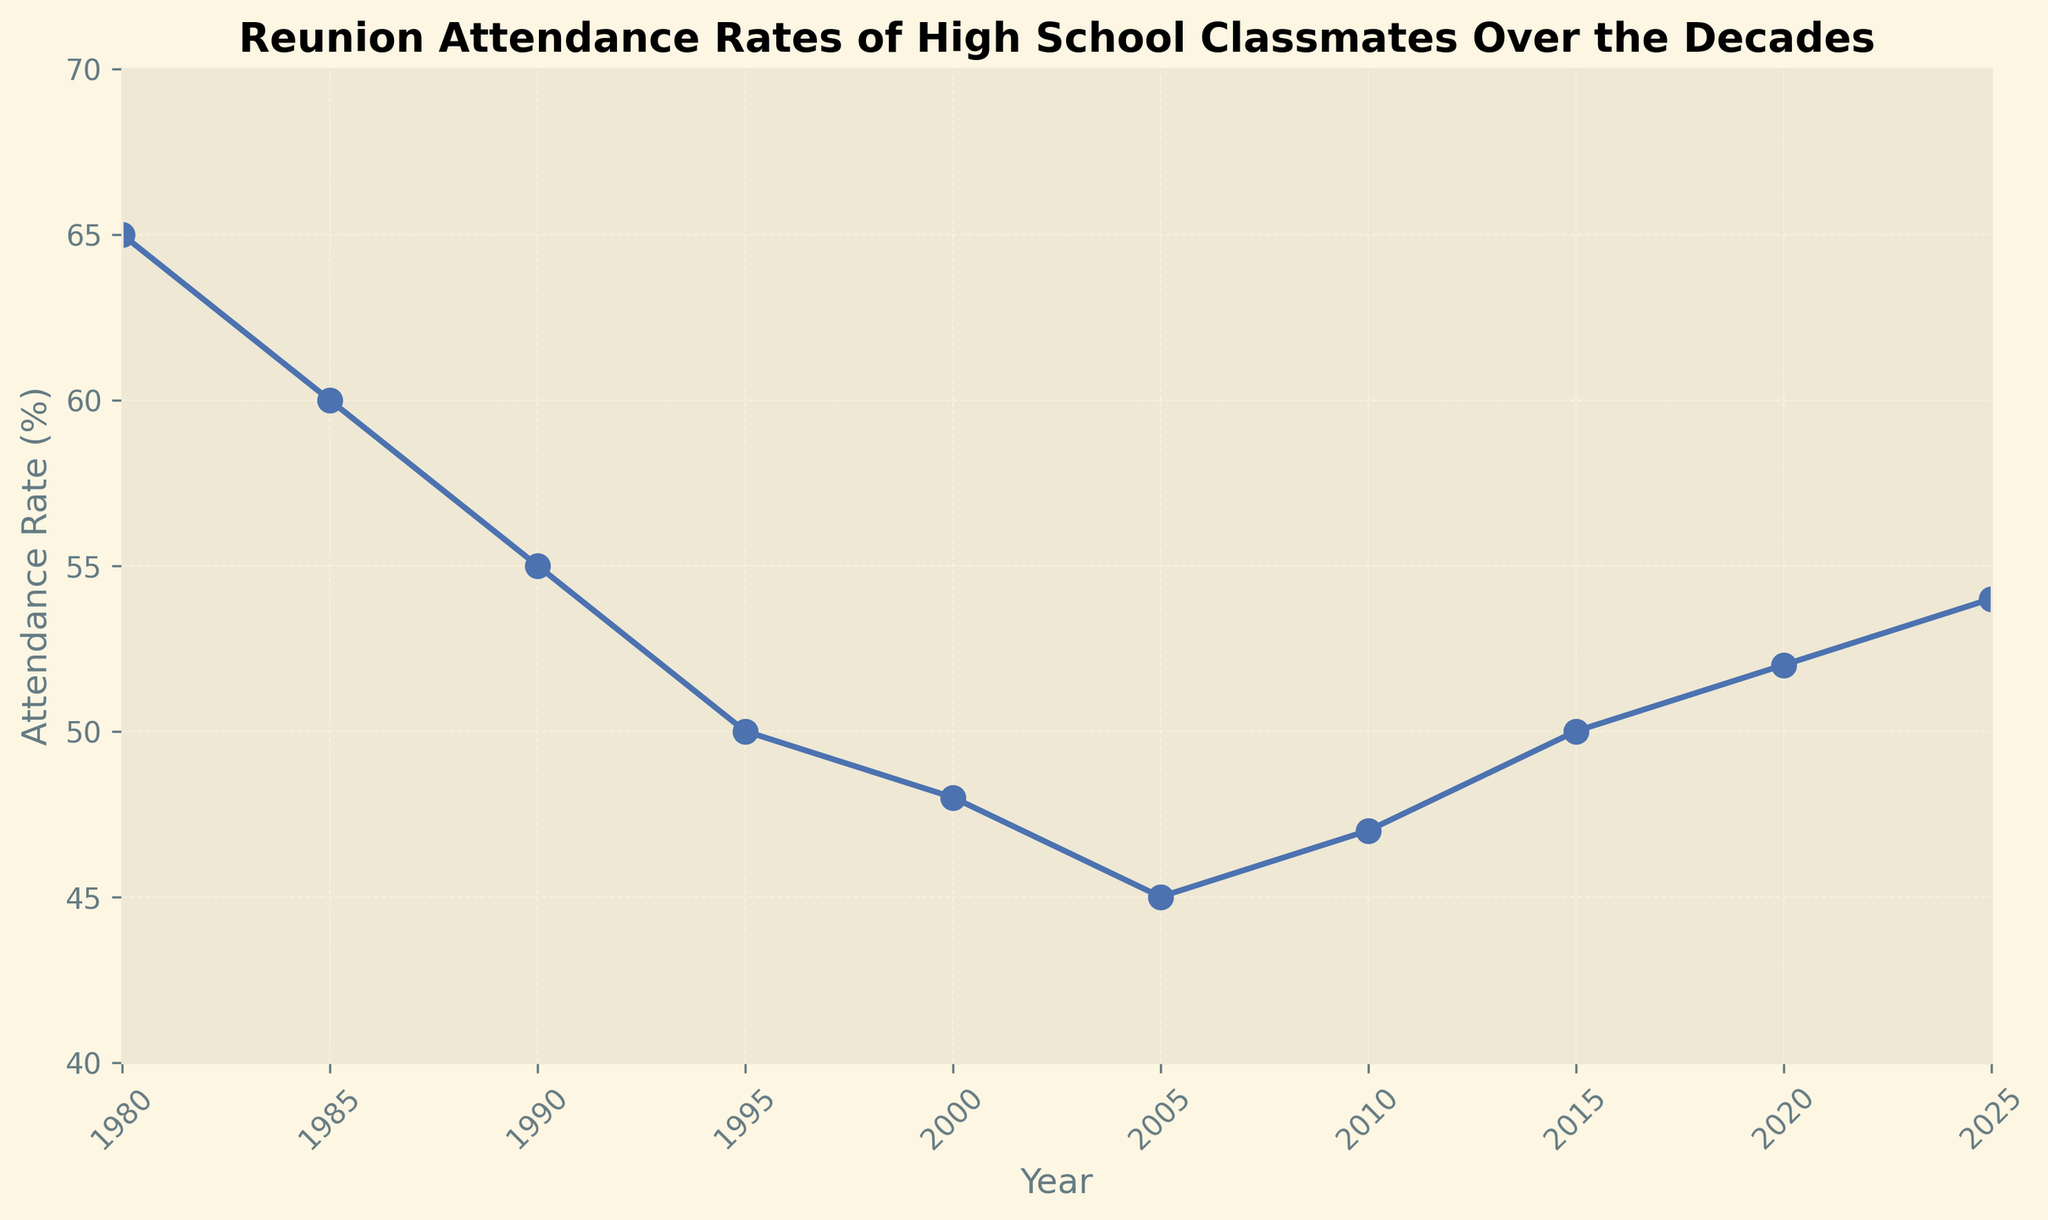what trend can be observed in the attendance rates from 1980 to 2025? The trend shows a general decline in attendance rates from 1980 (65%) to 2005 (45%), followed by a slight increase from 2005 onwards, reaching 54% by 2025.
Answer: A decline followed by a slight increase what is the difference in attendance rates between 1980 and 2005? The attendance rate in 1980 is 65%, and in 2005 it is 45%. The difference is calculated as 65% - 45% = 20%.
Answer: 20% between which consecutive years did the attendance rate decrease the most? The largest decrease in consecutive years happens between 1980 (65%) and 1985 (60%). The decrease is calculated as 65% - 60% = 5%.
Answer: 1980 and 1985 which year had the highest attendance rate, and what was it? By examining the plot, the year 1980 had the highest attendance rate with a value of 65%.
Answer: 1980, 65% what is the average attendance rate from 2000 to 2025? The attendance rates from 2000 to 2025 are 48%, 45%, 47%, 50%, 52%, and 54%. To find the average, sum these rates (48 + 45 + 47 + 50 + 52 + 54) = 296 and divide by 6, resulting in 296 / 6 = approx. 49.33%.
Answer: ~49.33% how does the attendance rate in 2010 compare to 2020? The attendance rate in 2010 is 47%, and in 2020 it is 52%. Comparing these, 52% is higher than 47% by 5 percentage points.
Answer: 2020 is higher by 5 percentage points what is the overall range of attendance rates shown in the figure? The highest value is 65% in 1980, and the lowest value is 45% in 2005. The range is calculated as 65% - 45% = 20%.
Answer: 20% in which decade did the greatest overall decline in attendance rate occur? From the chart, the greatest overall decade decline occurred from 1980 to 1990. In 1980 the rate was 65% and in 1990 it was 55%. The decline over the decade is 65% - 55% = 10%, which is the largest in a single decade.
Answer: 1980-1990 what does the shape of the plot from 2005 to 2025 tell us about the attendance trend? The plot shows an upward trend from 2005 (45%) with slight fluctuations, gradually increasing to 54% by 2025. This shape suggests that attendance rates have been recovering after 2005.
Answer: Recovering trend what can be inferred about the reunion attendance rates in the latest years of the figure compared to the earliest years? Early years (1980) had higher rates (65%), but a general decline occurred until 2005, after which attendance began to rise again, although it has not reached the initial high seen in 1980.
Answer: Early years were higher than recent years, with some recovery in recent years 